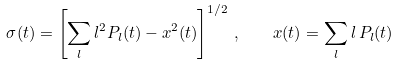Convert formula to latex. <formula><loc_0><loc_0><loc_500><loc_500>\sigma ( t ) = \left [ \sum _ { l } l ^ { 2 } P _ { l } ( t ) - x ^ { 2 } ( t ) \right ] ^ { 1 / 2 } \, , \quad x ( t ) = \sum _ { l } l \, P _ { l } ( t )</formula> 